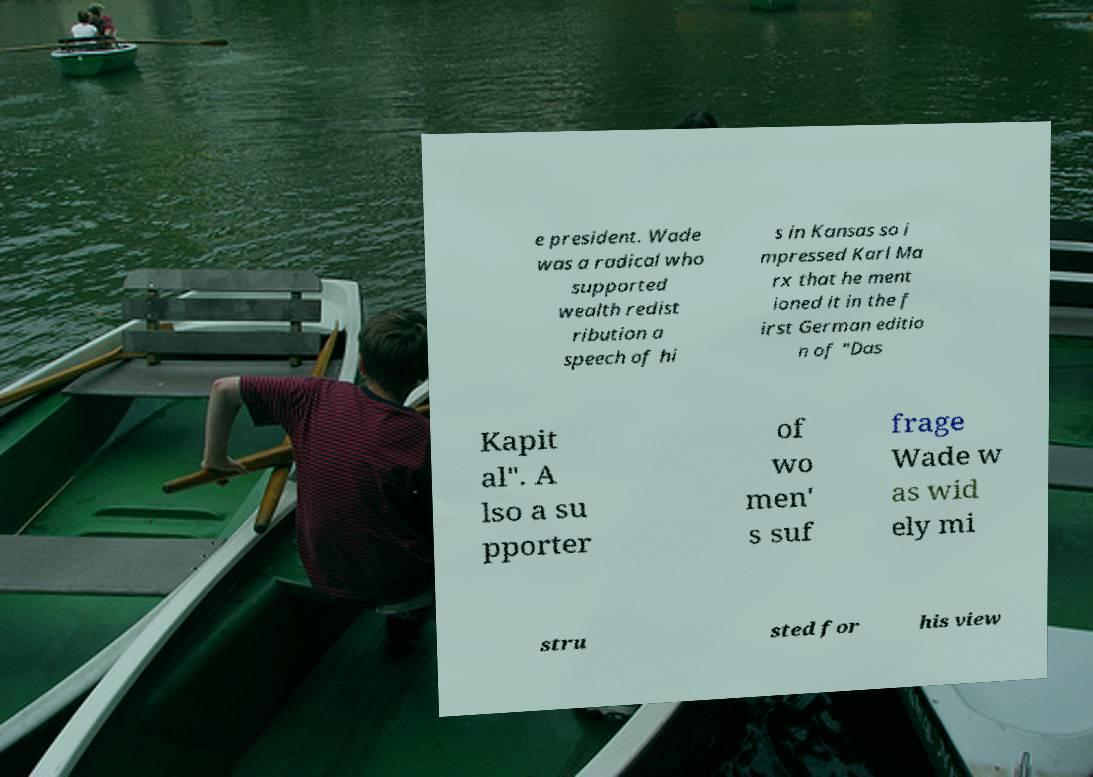For documentation purposes, I need the text within this image transcribed. Could you provide that? e president. Wade was a radical who supported wealth redist ribution a speech of hi s in Kansas so i mpressed Karl Ma rx that he ment ioned it in the f irst German editio n of "Das Kapit al". A lso a su pporter of wo men' s suf frage Wade w as wid ely mi stru sted for his view 